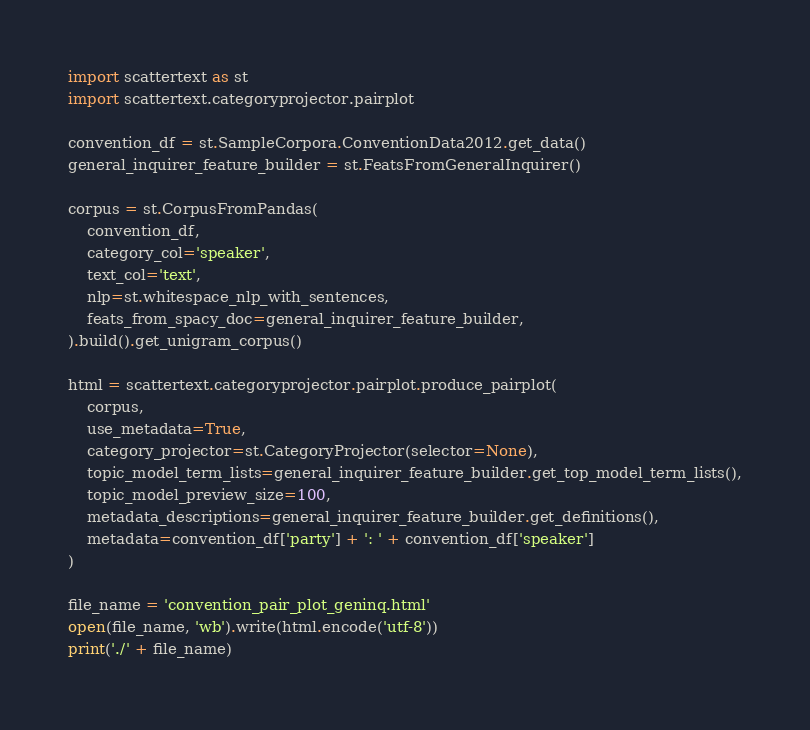<code> <loc_0><loc_0><loc_500><loc_500><_Python_>import scattertext as st
import scattertext.categoryprojector.pairplot

convention_df = st.SampleCorpora.ConventionData2012.get_data()
general_inquirer_feature_builder = st.FeatsFromGeneralInquirer()

corpus = st.CorpusFromPandas(
    convention_df,
    category_col='speaker',
    text_col='text',
    nlp=st.whitespace_nlp_with_sentences,
    feats_from_spacy_doc=general_inquirer_feature_builder,
).build().get_unigram_corpus()

html = scattertext.categoryprojector.pairplot.produce_pairplot(
    corpus,
    use_metadata=True,
    category_projector=st.CategoryProjector(selector=None),
    topic_model_term_lists=general_inquirer_feature_builder.get_top_model_term_lists(),
    topic_model_preview_size=100,
    metadata_descriptions=general_inquirer_feature_builder.get_definitions(),
    metadata=convention_df['party'] + ': ' + convention_df['speaker']
)

file_name = 'convention_pair_plot_geninq.html'
open(file_name, 'wb').write(html.encode('utf-8'))
print('./' + file_name)
</code> 